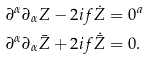<formula> <loc_0><loc_0><loc_500><loc_500>\partial ^ { \alpha } \partial _ { \alpha } Z - 2 i f \dot { Z } & = 0 ^ { a } \\ \partial ^ { \alpha } \partial _ { \alpha } \bar { Z } + 2 i f \dot { \bar { Z } } & = 0 .</formula> 